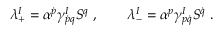<formula> <loc_0><loc_0><loc_500><loc_500>\lambda _ { + } ^ { I } = \alpha ^ { \dot { p } } \gamma _ { \dot { p } q } ^ { I } S ^ { q } \ , \quad \lambda _ { - } ^ { I } = \alpha ^ { p } \gamma _ { p \dot { q } } ^ { I } S ^ { \dot { q } } \ .</formula> 